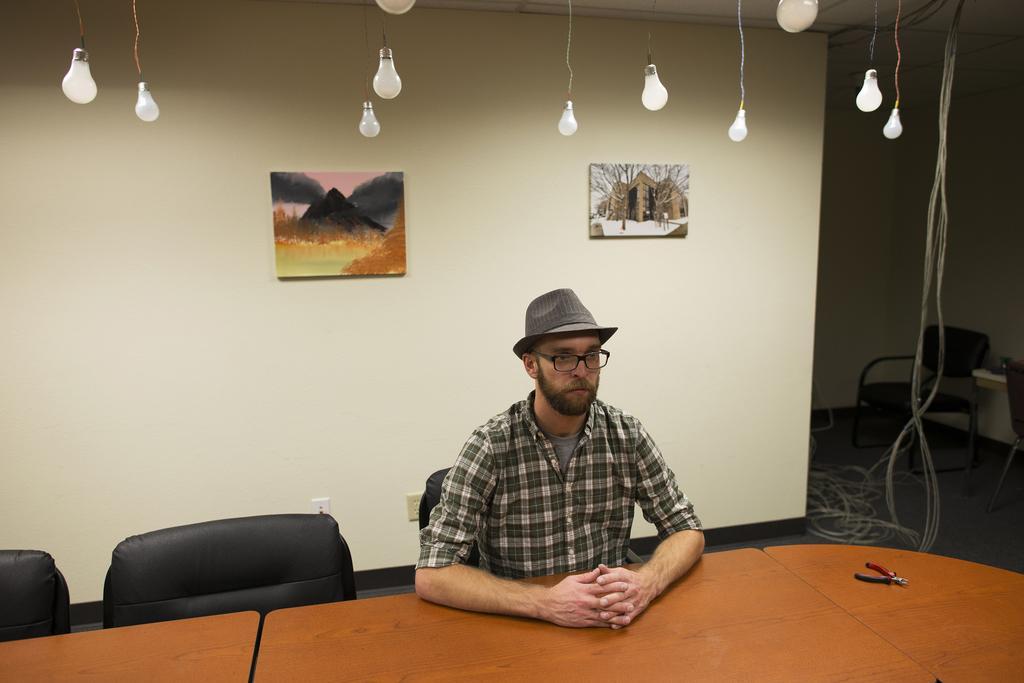Describe this image in one or two sentences. In this image I can see a man is sitting on a chair. I can also see he is wearing my specs, a hat and a shirt. In the background I can see 2 paintings on this Wall. Here I can see few bulbs and here I can see chairs and tables. In the background I can see few more chairs. 